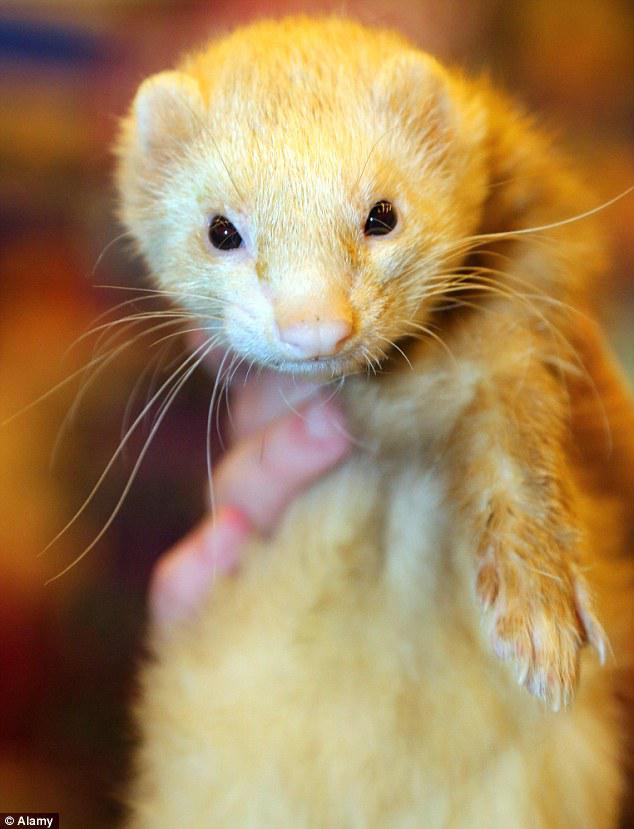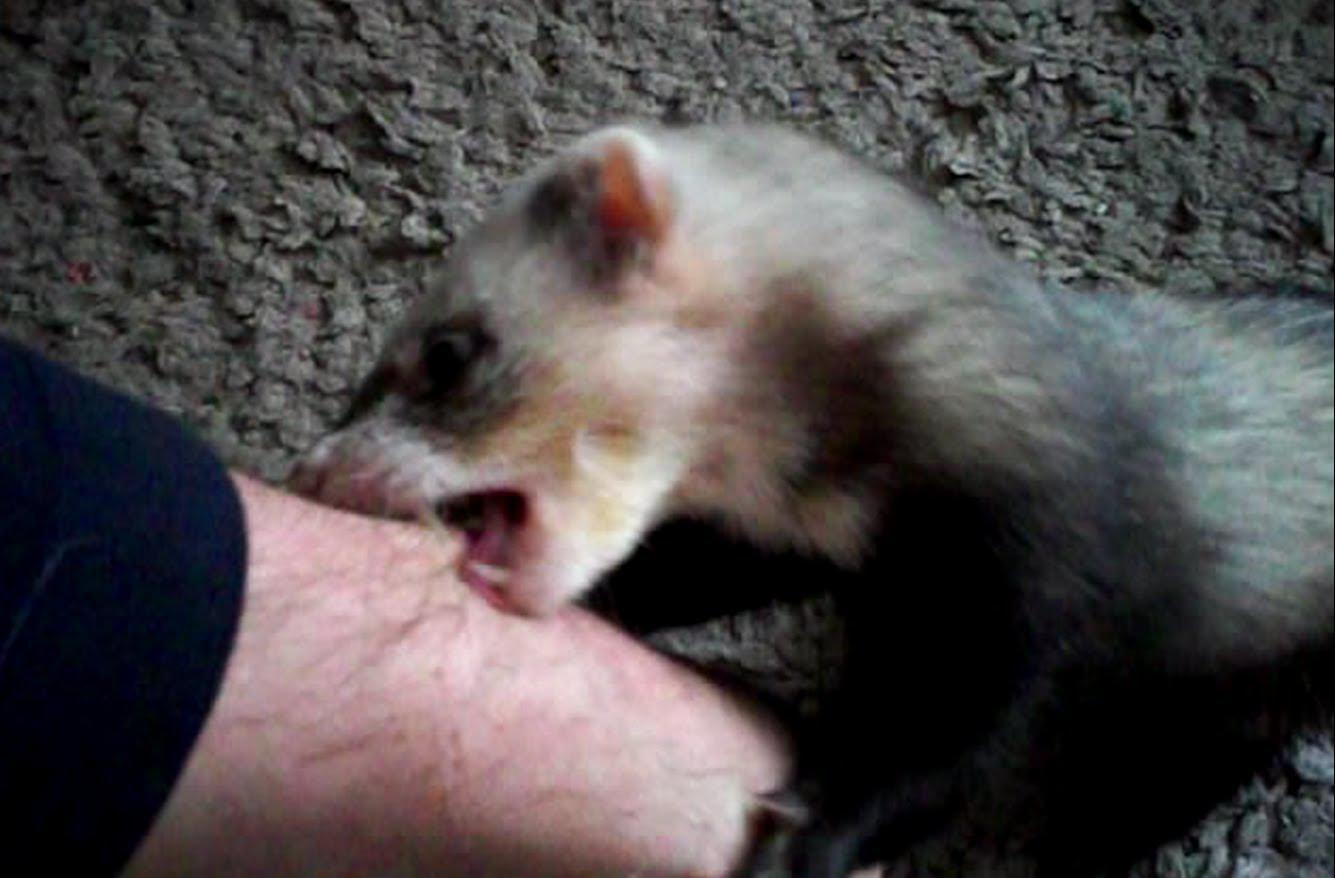The first image is the image on the left, the second image is the image on the right. Analyze the images presented: Is the assertion "There are three ferrets in one of the images." valid? Answer yes or no. No. 